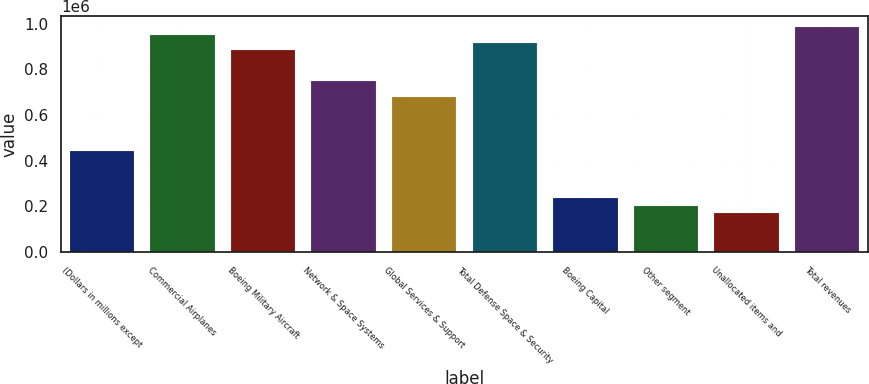Convert chart to OTSL. <chart><loc_0><loc_0><loc_500><loc_500><bar_chart><fcel>(Dollars in millions except<fcel>Commercial Airplanes<fcel>Boeing Military Aircraft<fcel>Network & Space Systems<fcel>Global Services & Support<fcel>Total Defense Space & Security<fcel>Boeing Capital<fcel>Other segment<fcel>Unallocated items and<fcel>Total revenues<nl><fcel>441554<fcel>951037<fcel>883105<fcel>747243<fcel>679312<fcel>917071<fcel>237760<fcel>203795<fcel>169829<fcel>985002<nl></chart> 